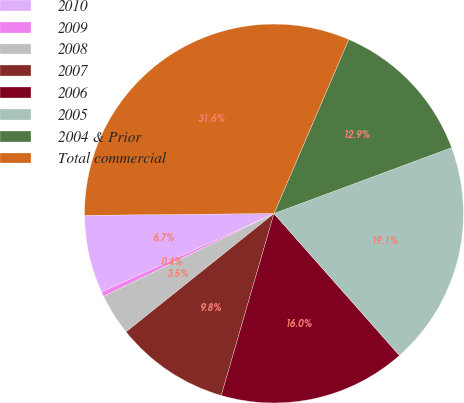Convert chart. <chart><loc_0><loc_0><loc_500><loc_500><pie_chart><fcel>2010<fcel>2009<fcel>2008<fcel>2007<fcel>2006<fcel>2005<fcel>2004 & Prior<fcel>Total commercial<nl><fcel>6.65%<fcel>0.41%<fcel>3.53%<fcel>9.77%<fcel>16.01%<fcel>19.13%<fcel>12.89%<fcel>31.61%<nl></chart> 